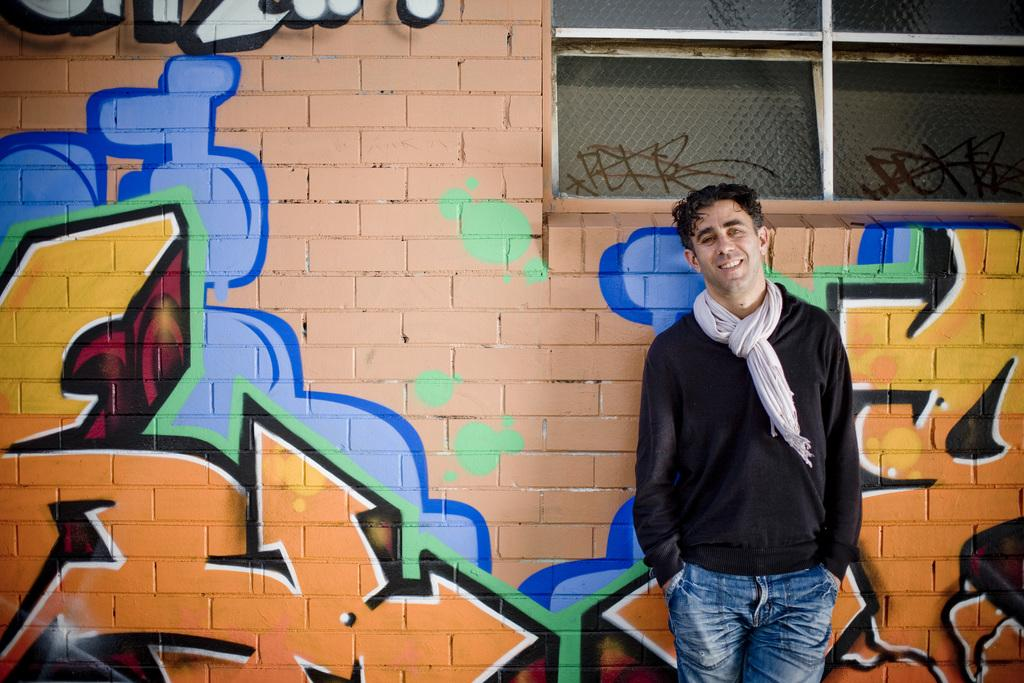Who is present in the image? There is a man in the image. What is the man's position in relation to the wall? The man is standing in front of a wall. What can be seen on the wall? There are paintings on the wall. What type of drug can be seen in the image? There is no drug present in the image. --- Facts: 1. There is a car in the image. 2. The car is red. 3. The car has four wheels. 4. The car is parked on the street. 5. There are people walking on the sidewalk. Absurd Topics: elephant, ocean, rainbow Conversation: What is the main subject in the image? There is a car in the image. What color is the car? The car is red. How many wheels does the car have? The car has four wheels. Where is the car located in the image? The car is parked on the street. What else can be seen in the image? There are people walking on the sidewalk. Reasoning: Let's think step by step in order to produce the conversation. We start by identifying the main subject of the image, which is the car. Then, we describe specific features of the car, such as its color and the number of wheels it has. Next, we observe the car's location in the image, which is parked on the street. Finally, we describe any additional elements present in the image, such as the people walking on the sidewalk. Absurd Question/Answer: Can you see an elephant in the image? No, there is no elephant present in the image. --- Facts: 1. There is a group of people in the image. 2. The people are wearing hats. 3. The people are holding hands. 4. The people are standing in a circle. 5. There is a large tree in the background. Absurd Topics: unicorn, flying saucer, outer space Conversation: How many people are in the image? There is a group of people in the image. What are the people wearing on their heads? The people are wearing hats. What are the people doing in the image? The people are holding hands. How are the people positioned in the image? The people are standing in a circle. What can be seen in the background of the image? There is a large tree in the background. Reasoning: Let's think step by step in order to produce the conversation. We start by identifying the main subject of the image, which is the group of people. Then, we describe specific features of the people, such as their clothing and the activity they are engaged in. Next, we observe the people's positioning in the image. Finally, we describe any additional elements present in the image, such as the large tree in 